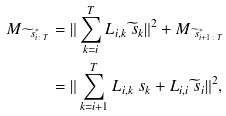<formula> <loc_0><loc_0><loc_500><loc_500>M _ { \widetilde { \ s } ^ { * } _ { i \colon T } } & = \| \sum ^ { T } _ { k = i } L _ { i , k } \widetilde { \ s } _ { k } \| ^ { 2 } + M _ { \widetilde { \ s } ^ { * } _ { i + 1 \colon T } } \\ & = \| \sum _ { k = i + 1 } ^ { T } L _ { i , k } \ s _ { k } + L _ { i , i } \widetilde { \ s } _ { i } \| ^ { 2 } , \\</formula> 